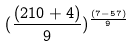<formula> <loc_0><loc_0><loc_500><loc_500>( \frac { ( 2 1 0 + 4 ) } { 9 } ) ^ { \frac { ( 7 - 5 7 ) } { 9 } }</formula> 